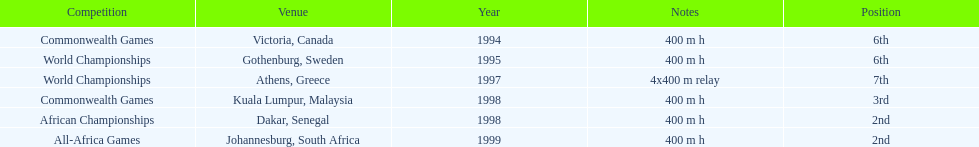On this chart, what is the cumulative number of competitions? 6. Write the full table. {'header': ['Competition', 'Venue', 'Year', 'Notes', 'Position'], 'rows': [['Commonwealth Games', 'Victoria, Canada', '1994', '400 m h', '6th'], ['World Championships', 'Gothenburg, Sweden', '1995', '400 m h', '6th'], ['World Championships', 'Athens, Greece', '1997', '4x400 m relay', '7th'], ['Commonwealth Games', 'Kuala Lumpur, Malaysia', '1998', '400 m h', '3rd'], ['African Championships', 'Dakar, Senegal', '1998', '400 m h', '2nd'], ['All-Africa Games', 'Johannesburg, South Africa', '1999', '400 m h', '2nd']]} 